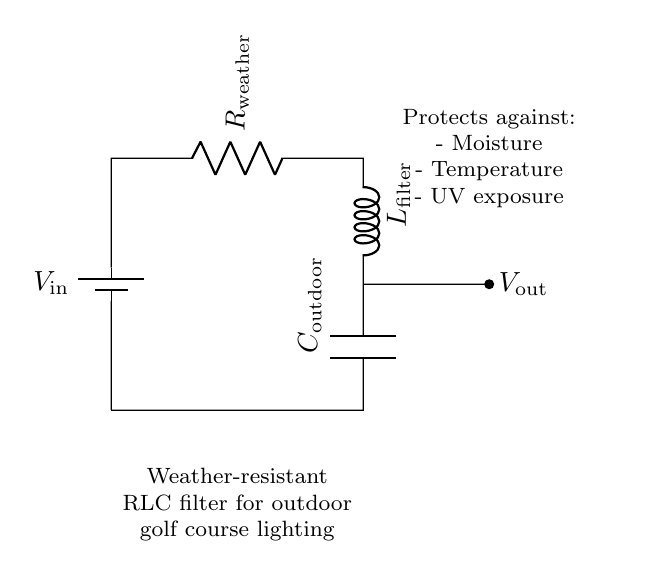What is the input voltage labeled in the circuit? The input voltage is labeled as V-in, which is the voltage source indicated at the left side of the circuit.
Answer: V-in What component is used to protect against moisture? The circuit diagram includes the resistor labeled R-weather, which is designated for weather resistance and helps protect the circuit against moisture.
Answer: R-weather Which component regulates the output voltage? The output voltage is regulated by the capacitor labeled C-outdoor, positioned at the lower part of the circuit.
Answer: C-outdoor What is the order of components from input to output? The components arranged from input to output in the circuit are: R-weather, L-filter, C-outdoor. This sequence follows the path from the voltage source to the output.
Answer: R-weather, L-filter, C-outdoor How many components are in the circuit? There are three main components in this RLC filter circuit: a resistor, an inductor, and a capacitor, totaling three components.
Answer: Three What environmental conditions can this filter withstand? The circuit is designed to withstand three specific conditions: moisture, temperature, and UV exposure, as noted in the diagram.
Answer: Moisture, temperature, UV exposure What type of circuit is represented here? This circuit represents a weather-resistant RLC filter, which utilizes a resistor, inductor, and capacitor in a series configuration for specific filtering applications.
Answer: RLC filter 